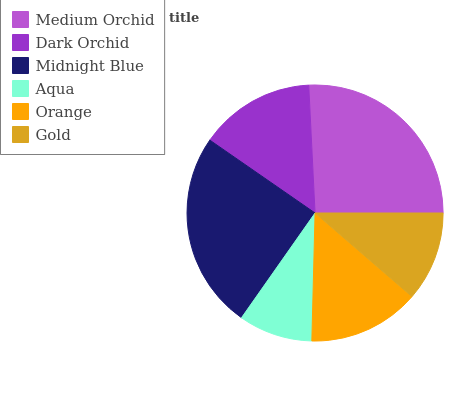Is Aqua the minimum?
Answer yes or no. Yes. Is Medium Orchid the maximum?
Answer yes or no. Yes. Is Dark Orchid the minimum?
Answer yes or no. No. Is Dark Orchid the maximum?
Answer yes or no. No. Is Medium Orchid greater than Dark Orchid?
Answer yes or no. Yes. Is Dark Orchid less than Medium Orchid?
Answer yes or no. Yes. Is Dark Orchid greater than Medium Orchid?
Answer yes or no. No. Is Medium Orchid less than Dark Orchid?
Answer yes or no. No. Is Dark Orchid the high median?
Answer yes or no. Yes. Is Orange the low median?
Answer yes or no. Yes. Is Medium Orchid the high median?
Answer yes or no. No. Is Medium Orchid the low median?
Answer yes or no. No. 